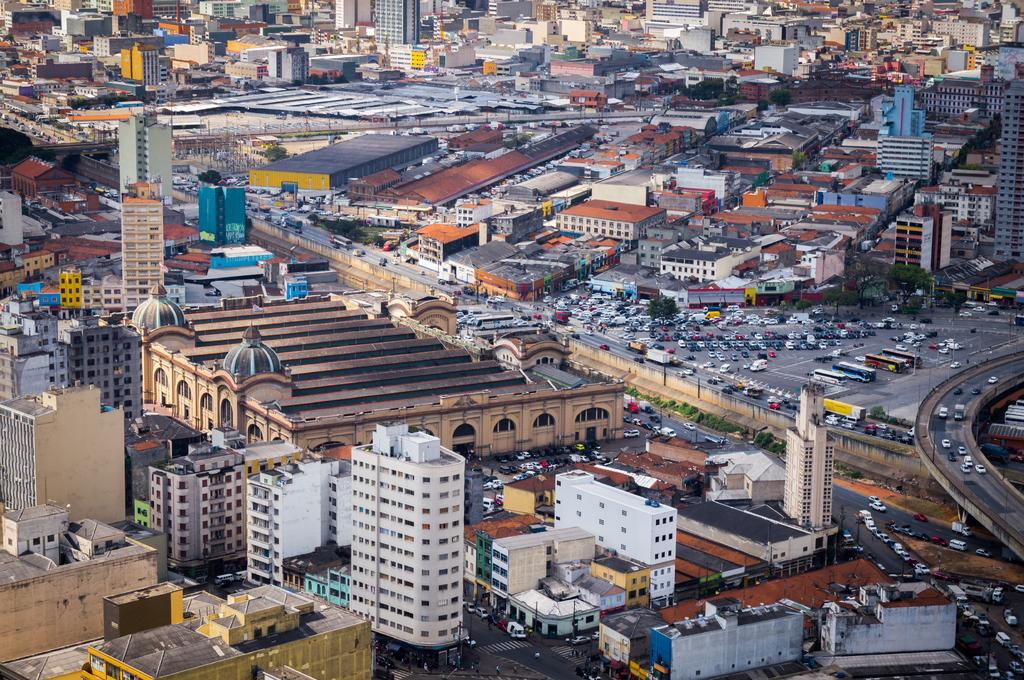What types of structures are present in the image? There are buildings and houses in the image. What natural elements can be seen in the image? There are trees in the image. What man-made elements are present in the image? There are vehicles, roads, and bridges in the image. Where is the robin perched on the hill in the image? There is no robin or hill present in the image. What type of bubble can be seen floating near the buildings in the image? There are no bubbles present in the image. 